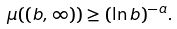<formula> <loc_0><loc_0><loc_500><loc_500>\mu ( ( b , \infty ) ) \geq ( \ln b ) ^ { - a } .</formula> 